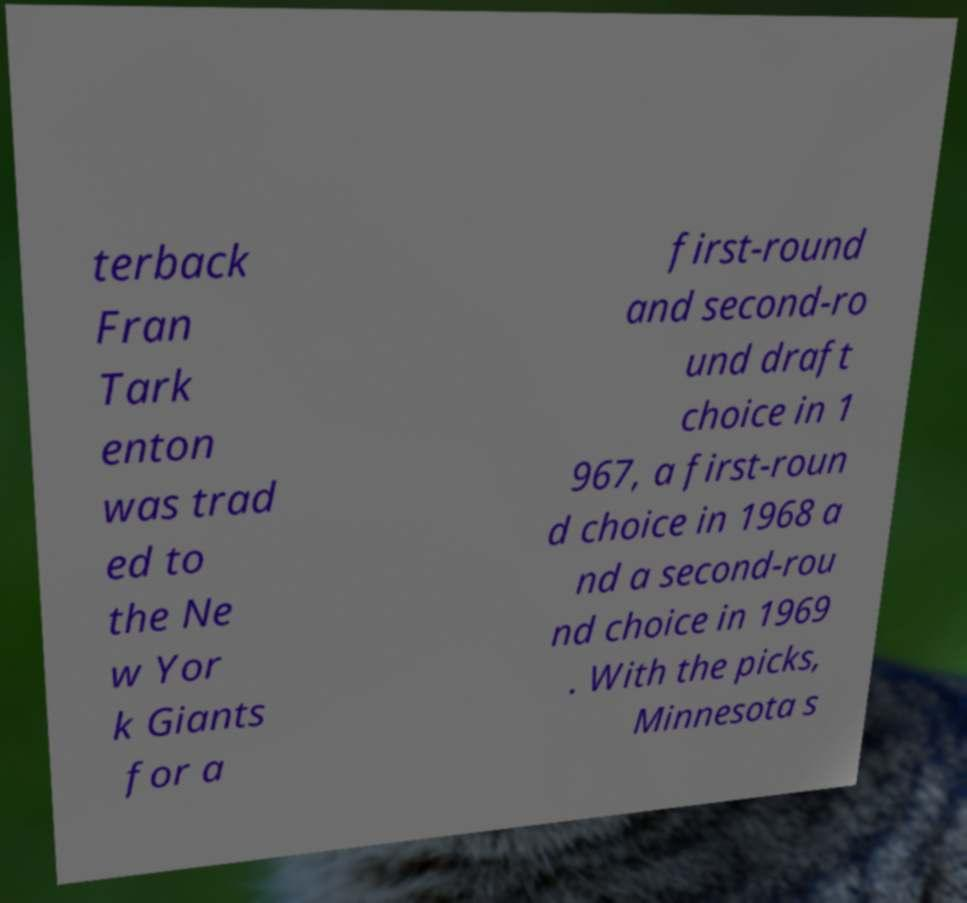There's text embedded in this image that I need extracted. Can you transcribe it verbatim? terback Fran Tark enton was trad ed to the Ne w Yor k Giants for a first-round and second-ro und draft choice in 1 967, a first-roun d choice in 1968 a nd a second-rou nd choice in 1969 . With the picks, Minnesota s 